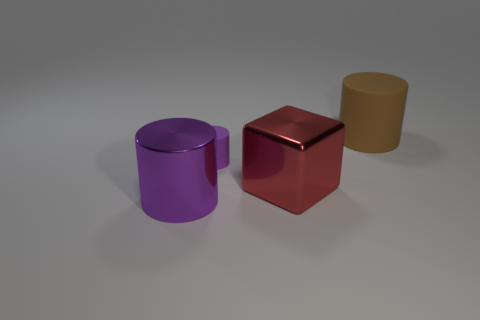Add 4 tiny purple cylinders. How many objects exist? 8 Subtract all cubes. How many objects are left? 3 Add 4 small purple cylinders. How many small purple cylinders are left? 5 Add 1 small green objects. How many small green objects exist? 1 Subtract 0 green cylinders. How many objects are left? 4 Subtract all small green shiny balls. Subtract all purple cylinders. How many objects are left? 2 